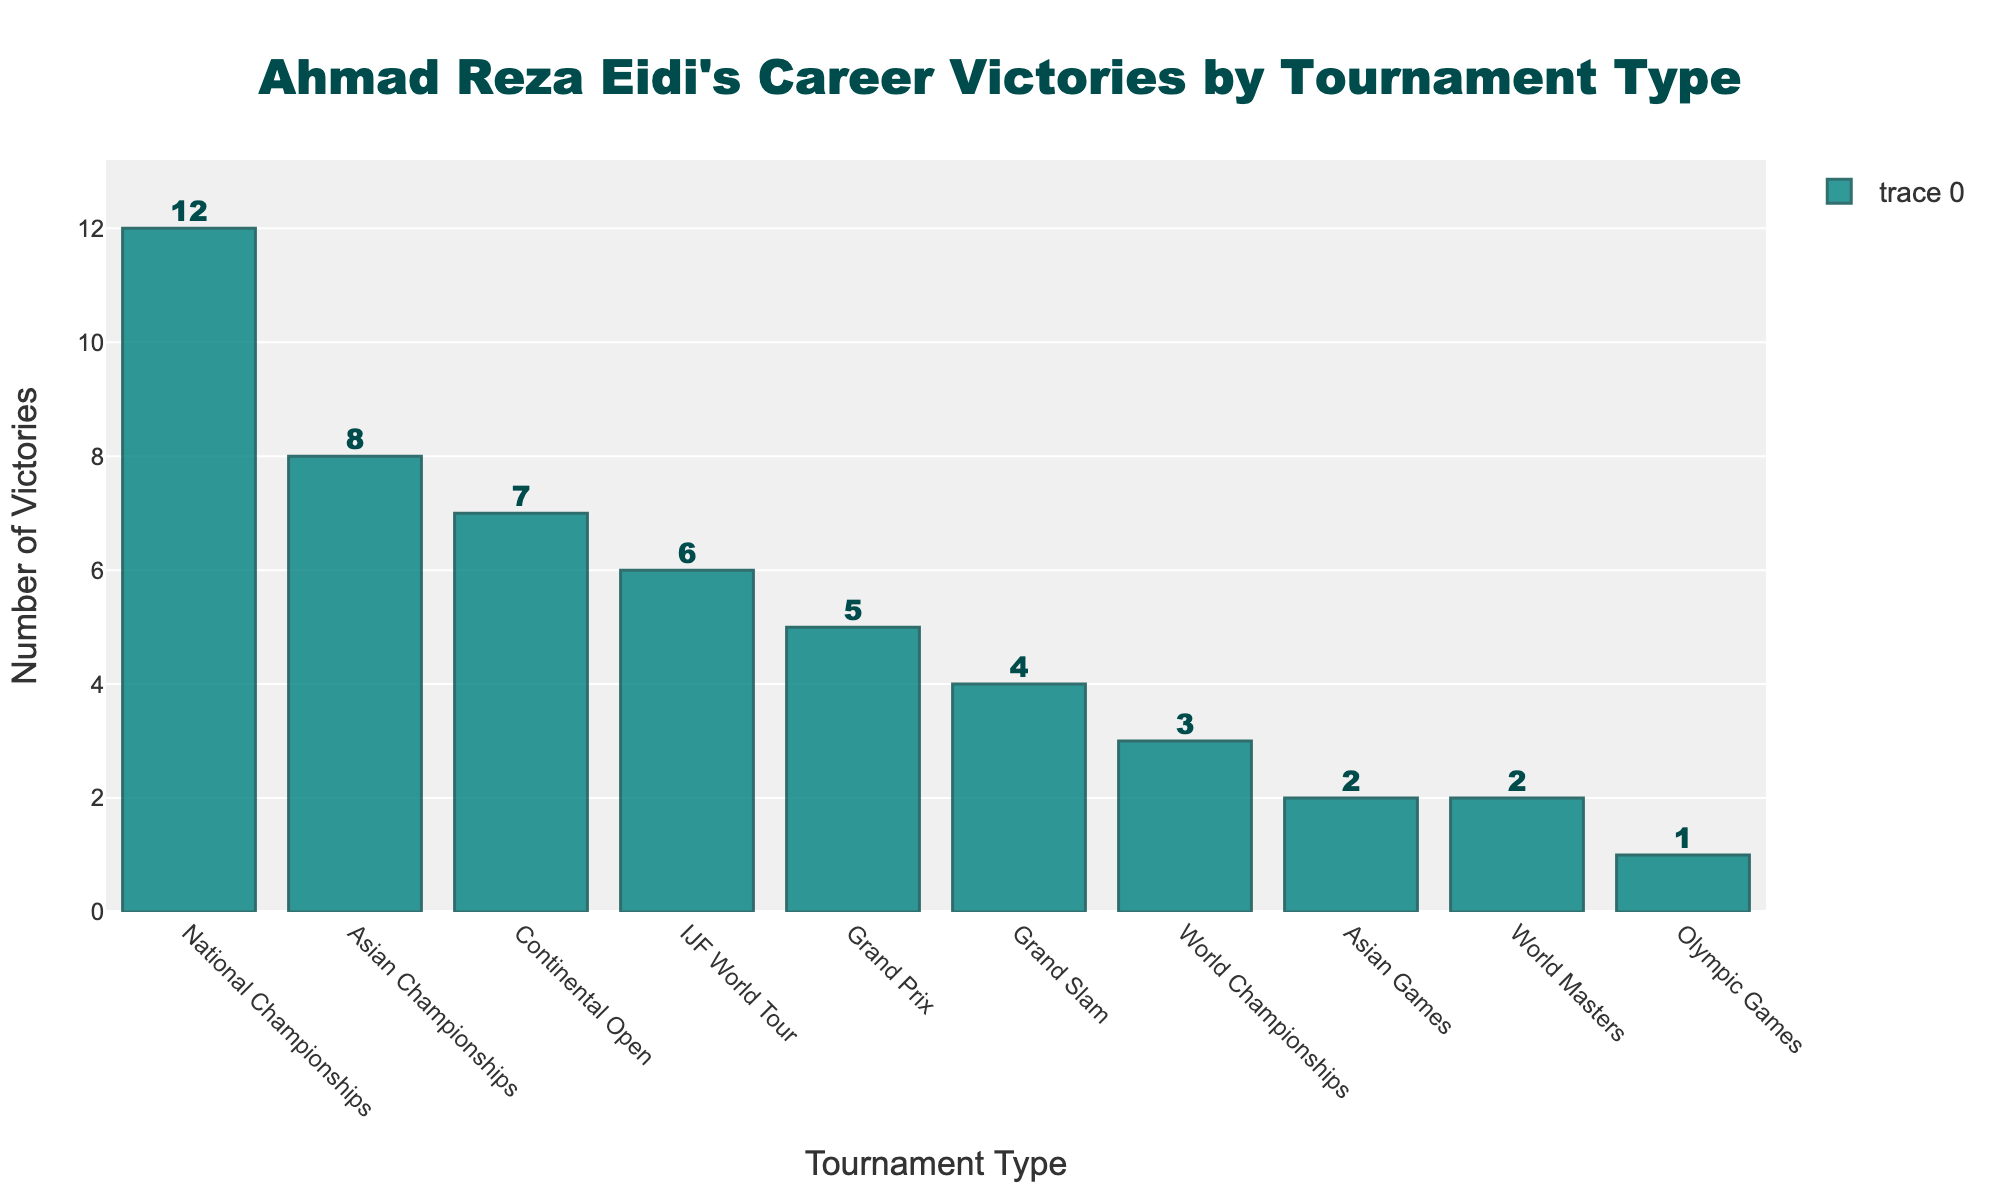What tournament sees the highest number of victories for Ahmad Reza Eidi? The bar for "National Championships" is the tallest in the chart. Therefore, it has the highest number of victories.
Answer: National Championships Which tournament types have Ahmad Reza Eidi won exactly 2 times? The bars for "Asian Games" and "World Masters" reach up to the mark of 2 victories on the y-axis.
Answer: Asian Games, World Masters How many more victories does Ahmad Reza Eidi have in IJF World Tour compared to Grand Slam tournaments? The IJF World Tour has 6 victories, and the Grand Slam tournaments have 4 victories. The difference is 6 - 4.
Answer: 2 What is the total number of victories Ahmad Reza Eidi has in World Championships and Grand Slam tournaments combined? Ahmad Reza Eidi has 3 victories in World Championships and 4 victories in Grand Slam tournaments. Combined, this is 3 + 4.
Answer: 7 Which tournament type has Ahmad Reza Eidi won less than IJF World Tour but more than Asian Championships? Continental Open has 7 victories, which is less than the 6 victories in IJF World Tour and more than the 8 victories in Asian Championships.
Answer: Continental Open What is the third most won tournament type by Ahmad Reza Eidi? By ordering the bars by height, the third tallest bar corresponds to the "Asian Championships" with 8 victories.
Answer: Asian Championships How does the total number of victories in Continental Open compare to the total in Grand Slam and Grand Prix combined? Continental Open has 7 victories. Grand Slam has 4 victories, and Grand Prix has 5 victories, combined 4 + 5 = 9. Comparing 7 and 9, Grand Slam and Grand Prix combined have 2 more victories.
Answer: Combined Grand Slam and Grand Prix have 2 more victories What are the victory counts for tournaments that Ahmad Reza Eidi has won 5 or fewer times? The bars for Grand Prix, Grand Slam, Asian Games, World Masters, and Olympic Games are at or below 5 victories. Grand Prix: 5, Grand Slam: 4, Asian Games: 2, World Masters: 2, Olympic Games: 1.
Answer: Grand Prix: 5, Grand Slam: 4, Asian Games: 2, World Masters: 2, Olympic Games: 1 